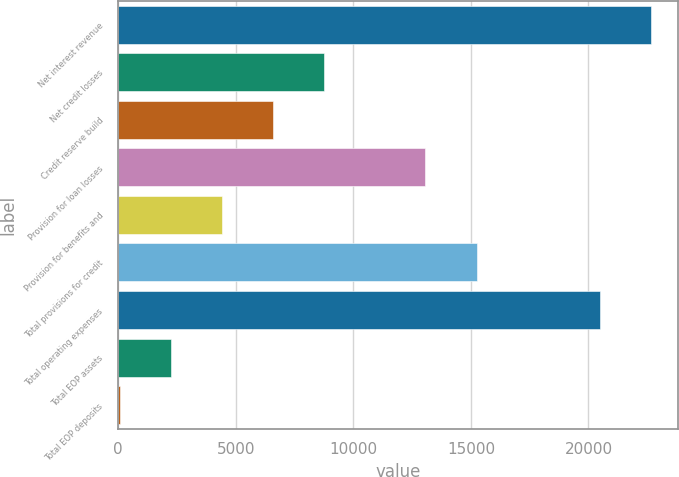Convert chart to OTSL. <chart><loc_0><loc_0><loc_500><loc_500><bar_chart><fcel>Net interest revenue<fcel>Net credit losses<fcel>Credit reserve build<fcel>Provision for loan losses<fcel>Provision for benefits and<fcel>Total provisions for credit<fcel>Total operating expenses<fcel>Total EOP assets<fcel>Total EOP deposits<nl><fcel>22658.8<fcel>8766.2<fcel>6594.4<fcel>13066<fcel>4422.6<fcel>15237.8<fcel>20487<fcel>2250.8<fcel>79<nl></chart> 